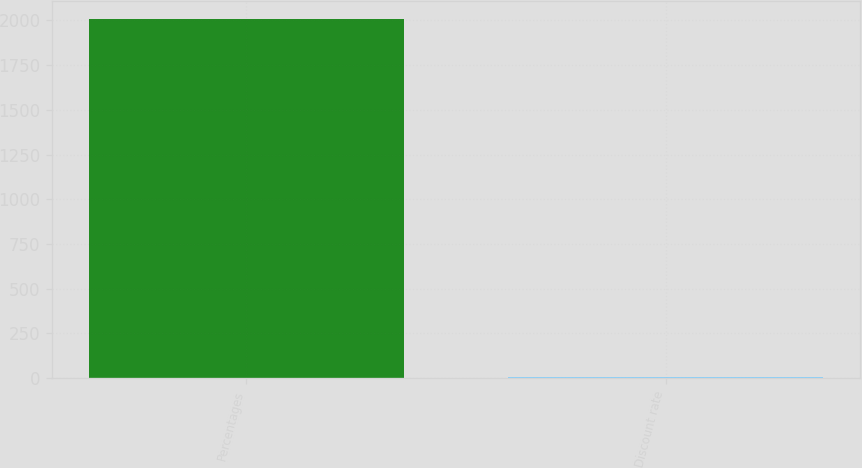Convert chart to OTSL. <chart><loc_0><loc_0><loc_500><loc_500><bar_chart><fcel>Percentages<fcel>Discount rate<nl><fcel>2011<fcel>4.82<nl></chart> 